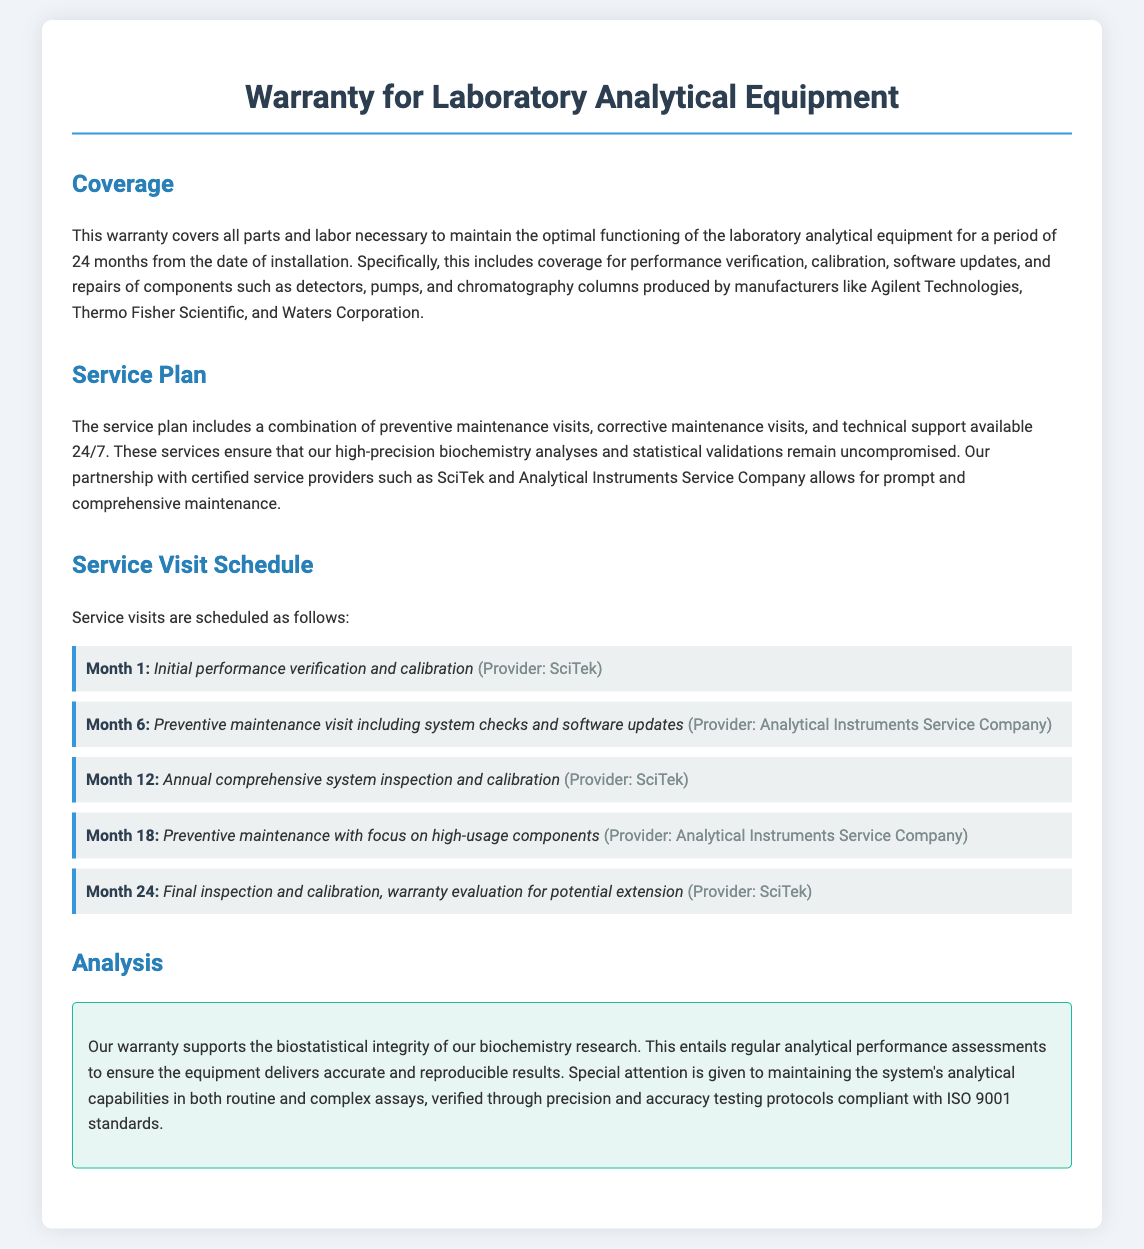What is the warranty period for the laboratory equipment? The warranty period is for a duration of 24 months from the date of installation.
Answer: 24 months Who are the manufacturers covered under the warranty? The warranty covers components produced by manufacturers like Agilent Technologies, Thermo Fisher Scientific, and Waters Corporation.
Answer: Agilent Technologies, Thermo Fisher Scientific, Waters Corporation When is the annual comprehensive system inspection scheduled? The annual comprehensive system inspection is scheduled for Month 12.
Answer: Month 12 What type of maintenance is performed in Month 6? The maintenance performed in Month 6 includes preventive maintenance visit including system checks and software updates.
Answer: Preventive maintenance Which provider conducts the final inspection in Month 24? The provider conducting the final inspection in Month 24 is SciTek.
Answer: SciTek What standards are the precision and accuracy testing protocols compliant with? The testing protocols are compliant with ISO 9001 standards.
Answer: ISO 9001 What does the analysis section emphasize regarding equipment functionality? The analysis section emphasizes the equipment delivers accurate and reproducible results.
Answer: Accurate and reproducible results How many service visits are scheduled in total during the warranty period? There are five service visits scheduled during the warranty period.
Answer: Five 